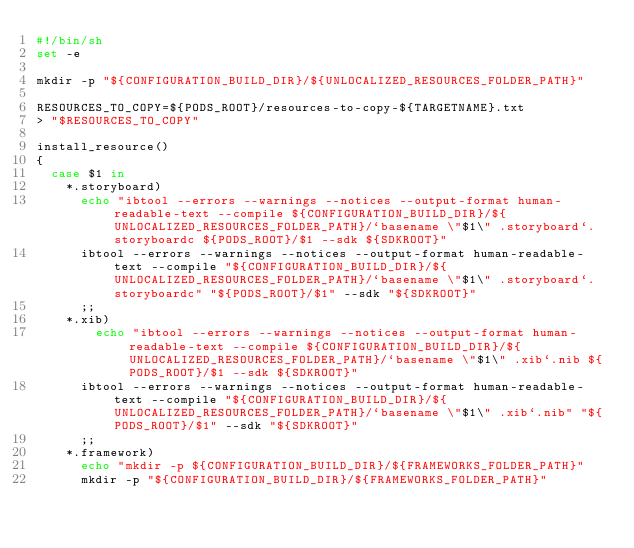Convert code to text. <code><loc_0><loc_0><loc_500><loc_500><_Bash_>#!/bin/sh
set -e

mkdir -p "${CONFIGURATION_BUILD_DIR}/${UNLOCALIZED_RESOURCES_FOLDER_PATH}"

RESOURCES_TO_COPY=${PODS_ROOT}/resources-to-copy-${TARGETNAME}.txt
> "$RESOURCES_TO_COPY"

install_resource()
{
  case $1 in
    *.storyboard)
      echo "ibtool --errors --warnings --notices --output-format human-readable-text --compile ${CONFIGURATION_BUILD_DIR}/${UNLOCALIZED_RESOURCES_FOLDER_PATH}/`basename \"$1\" .storyboard`.storyboardc ${PODS_ROOT}/$1 --sdk ${SDKROOT}"
      ibtool --errors --warnings --notices --output-format human-readable-text --compile "${CONFIGURATION_BUILD_DIR}/${UNLOCALIZED_RESOURCES_FOLDER_PATH}/`basename \"$1\" .storyboard`.storyboardc" "${PODS_ROOT}/$1" --sdk "${SDKROOT}"
      ;;
    *.xib)
        echo "ibtool --errors --warnings --notices --output-format human-readable-text --compile ${CONFIGURATION_BUILD_DIR}/${UNLOCALIZED_RESOURCES_FOLDER_PATH}/`basename \"$1\" .xib`.nib ${PODS_ROOT}/$1 --sdk ${SDKROOT}"
      ibtool --errors --warnings --notices --output-format human-readable-text --compile "${CONFIGURATION_BUILD_DIR}/${UNLOCALIZED_RESOURCES_FOLDER_PATH}/`basename \"$1\" .xib`.nib" "${PODS_ROOT}/$1" --sdk "${SDKROOT}"
      ;;
    *.framework)
      echo "mkdir -p ${CONFIGURATION_BUILD_DIR}/${FRAMEWORKS_FOLDER_PATH}"
      mkdir -p "${CONFIGURATION_BUILD_DIR}/${FRAMEWORKS_FOLDER_PATH}"</code> 